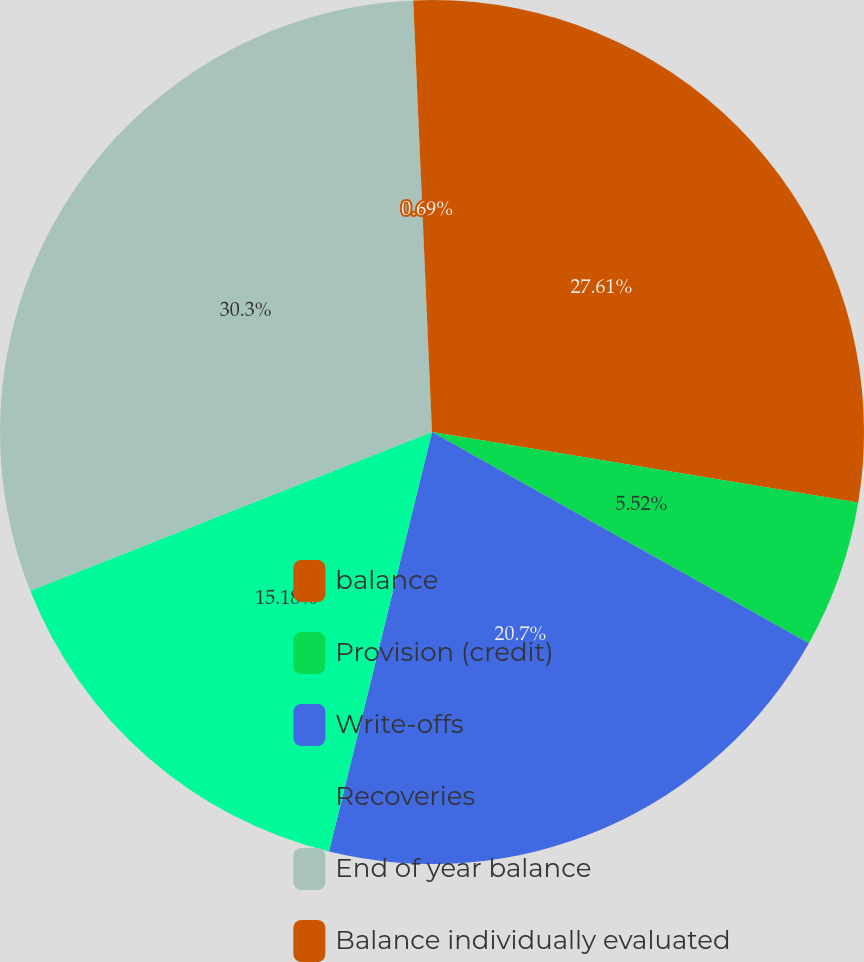Convert chart to OTSL. <chart><loc_0><loc_0><loc_500><loc_500><pie_chart><fcel>balance<fcel>Provision (credit)<fcel>Write-offs<fcel>Recoveries<fcel>End of year balance<fcel>Balance individually evaluated<nl><fcel>27.61%<fcel>5.52%<fcel>20.7%<fcel>15.18%<fcel>30.3%<fcel>0.69%<nl></chart> 